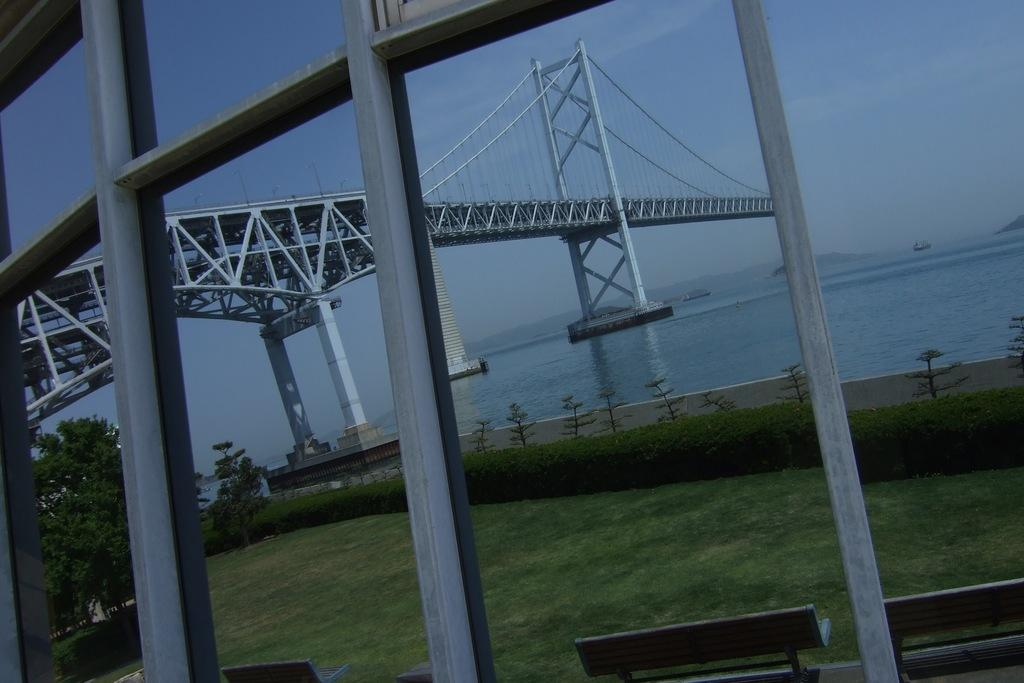What type of seating is available on the ground in the image? There are benches on the ground in the image. What type of vegetation is present in the image? Grass, plants, and trees are visible in the image. What type of structures are visible in the image? Rods and a bridge are visible in the image. What type of surface is the water on? The water is visible in the image. What can be seen in the background of the image? The sky is visible in the background of the image. How many roots can be seen growing from the bridge in the image? There are no roots visible in the image, as the bridge is not a plant. What type of animal is using its fang to climb the trees in the image? There are no animals present in the image, let alone one with a fang. 